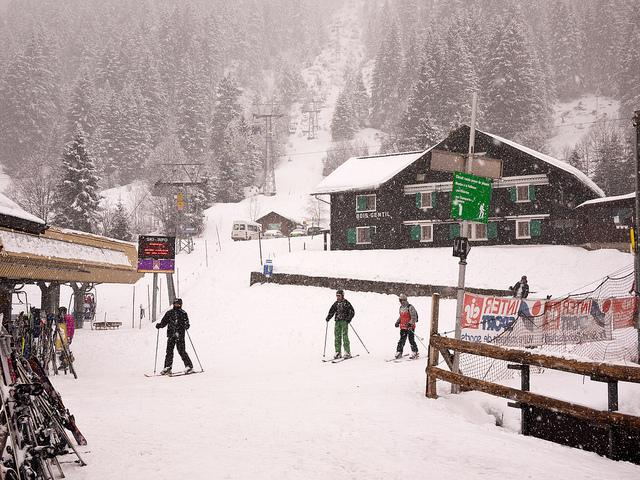What kind of stand is shown? Please explain your reasoning. rental. It's a place you can stay just a few days. 